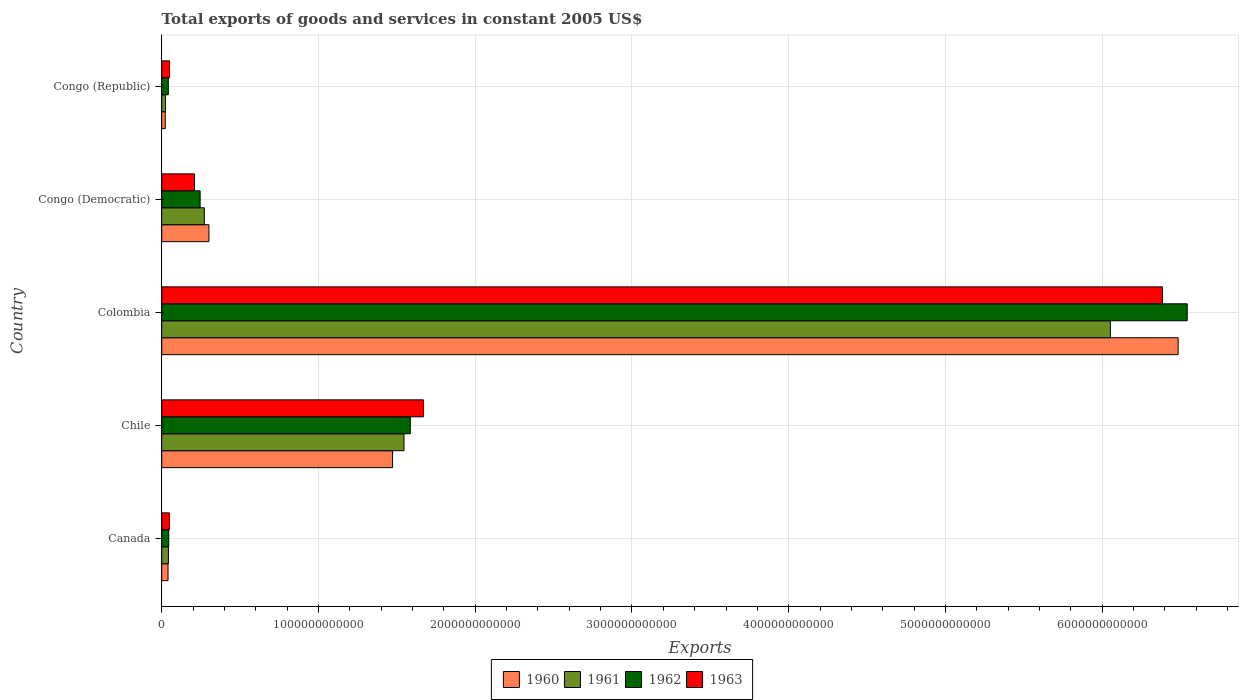How many different coloured bars are there?
Offer a very short reply. 4. How many groups of bars are there?
Your answer should be compact. 5. Are the number of bars per tick equal to the number of legend labels?
Give a very brief answer. Yes. How many bars are there on the 1st tick from the top?
Ensure brevity in your answer.  4. How many bars are there on the 2nd tick from the bottom?
Make the answer very short. 4. What is the label of the 1st group of bars from the top?
Give a very brief answer. Congo (Republic). What is the total exports of goods and services in 1962 in Congo (Republic)?
Your answer should be very brief. 4.20e+1. Across all countries, what is the maximum total exports of goods and services in 1960?
Your answer should be compact. 6.48e+12. Across all countries, what is the minimum total exports of goods and services in 1963?
Give a very brief answer. 4.91e+1. In which country was the total exports of goods and services in 1962 minimum?
Your answer should be very brief. Congo (Republic). What is the total total exports of goods and services in 1960 in the graph?
Provide a short and direct response. 8.32e+12. What is the difference between the total exports of goods and services in 1961 in Canada and that in Congo (Republic)?
Offer a very short reply. 1.87e+1. What is the difference between the total exports of goods and services in 1960 in Colombia and the total exports of goods and services in 1962 in Chile?
Your response must be concise. 4.90e+12. What is the average total exports of goods and services in 1963 per country?
Provide a short and direct response. 1.67e+12. What is the difference between the total exports of goods and services in 1961 and total exports of goods and services in 1963 in Canada?
Provide a short and direct response. -6.12e+09. What is the ratio of the total exports of goods and services in 1960 in Chile to that in Congo (Republic)?
Provide a short and direct response. 65.38. Is the total exports of goods and services in 1963 in Canada less than that in Congo (Democratic)?
Make the answer very short. Yes. Is the difference between the total exports of goods and services in 1961 in Congo (Democratic) and Congo (Republic) greater than the difference between the total exports of goods and services in 1963 in Congo (Democratic) and Congo (Republic)?
Your answer should be very brief. Yes. What is the difference between the highest and the second highest total exports of goods and services in 1962?
Offer a terse response. 4.96e+12. What is the difference between the highest and the lowest total exports of goods and services in 1962?
Offer a terse response. 6.50e+12. Is it the case that in every country, the sum of the total exports of goods and services in 1961 and total exports of goods and services in 1962 is greater than the sum of total exports of goods and services in 1960 and total exports of goods and services in 1963?
Provide a succinct answer. No. What does the 1st bar from the top in Chile represents?
Provide a succinct answer. 1963. How many bars are there?
Give a very brief answer. 20. What is the difference between two consecutive major ticks on the X-axis?
Offer a terse response. 1.00e+12. Are the values on the major ticks of X-axis written in scientific E-notation?
Keep it short and to the point. No. Does the graph contain any zero values?
Make the answer very short. No. Does the graph contain grids?
Give a very brief answer. Yes. How many legend labels are there?
Make the answer very short. 4. How are the legend labels stacked?
Make the answer very short. Horizontal. What is the title of the graph?
Provide a succinct answer. Total exports of goods and services in constant 2005 US$. What is the label or title of the X-axis?
Make the answer very short. Exports. What is the Exports of 1960 in Canada?
Provide a succinct answer. 4.02e+1. What is the Exports in 1961 in Canada?
Provide a short and direct response. 4.29e+1. What is the Exports in 1962 in Canada?
Ensure brevity in your answer.  4.49e+1. What is the Exports in 1963 in Canada?
Provide a succinct answer. 4.91e+1. What is the Exports of 1960 in Chile?
Your answer should be very brief. 1.47e+12. What is the Exports of 1961 in Chile?
Your answer should be very brief. 1.55e+12. What is the Exports of 1962 in Chile?
Your answer should be compact. 1.59e+12. What is the Exports in 1963 in Chile?
Provide a succinct answer. 1.67e+12. What is the Exports of 1960 in Colombia?
Offer a very short reply. 6.48e+12. What is the Exports of 1961 in Colombia?
Your answer should be very brief. 6.05e+12. What is the Exports in 1962 in Colombia?
Offer a very short reply. 6.54e+12. What is the Exports of 1963 in Colombia?
Keep it short and to the point. 6.38e+12. What is the Exports of 1960 in Congo (Democratic)?
Your answer should be very brief. 3.01e+11. What is the Exports of 1961 in Congo (Democratic)?
Provide a succinct answer. 2.72e+11. What is the Exports in 1962 in Congo (Democratic)?
Make the answer very short. 2.45e+11. What is the Exports in 1963 in Congo (Democratic)?
Provide a succinct answer. 2.09e+11. What is the Exports of 1960 in Congo (Republic)?
Ensure brevity in your answer.  2.25e+1. What is the Exports in 1961 in Congo (Republic)?
Give a very brief answer. 2.42e+1. What is the Exports of 1962 in Congo (Republic)?
Provide a succinct answer. 4.20e+1. What is the Exports in 1963 in Congo (Republic)?
Your answer should be very brief. 5.01e+1. Across all countries, what is the maximum Exports of 1960?
Provide a short and direct response. 6.48e+12. Across all countries, what is the maximum Exports of 1961?
Provide a succinct answer. 6.05e+12. Across all countries, what is the maximum Exports in 1962?
Give a very brief answer. 6.54e+12. Across all countries, what is the maximum Exports in 1963?
Make the answer very short. 6.38e+12. Across all countries, what is the minimum Exports of 1960?
Offer a very short reply. 2.25e+1. Across all countries, what is the minimum Exports in 1961?
Make the answer very short. 2.42e+1. Across all countries, what is the minimum Exports of 1962?
Offer a very short reply. 4.20e+1. Across all countries, what is the minimum Exports of 1963?
Make the answer very short. 4.91e+1. What is the total Exports in 1960 in the graph?
Provide a short and direct response. 8.32e+12. What is the total Exports of 1961 in the graph?
Give a very brief answer. 7.94e+12. What is the total Exports of 1962 in the graph?
Give a very brief answer. 8.46e+12. What is the total Exports in 1963 in the graph?
Offer a very short reply. 8.36e+12. What is the difference between the Exports in 1960 in Canada and that in Chile?
Offer a very short reply. -1.43e+12. What is the difference between the Exports of 1961 in Canada and that in Chile?
Offer a terse response. -1.50e+12. What is the difference between the Exports of 1962 in Canada and that in Chile?
Ensure brevity in your answer.  -1.54e+12. What is the difference between the Exports of 1963 in Canada and that in Chile?
Your response must be concise. -1.62e+12. What is the difference between the Exports in 1960 in Canada and that in Colombia?
Keep it short and to the point. -6.44e+12. What is the difference between the Exports of 1961 in Canada and that in Colombia?
Ensure brevity in your answer.  -6.01e+12. What is the difference between the Exports of 1962 in Canada and that in Colombia?
Provide a succinct answer. -6.50e+12. What is the difference between the Exports in 1963 in Canada and that in Colombia?
Offer a very short reply. -6.34e+12. What is the difference between the Exports in 1960 in Canada and that in Congo (Democratic)?
Offer a terse response. -2.61e+11. What is the difference between the Exports in 1961 in Canada and that in Congo (Democratic)?
Your answer should be compact. -2.29e+11. What is the difference between the Exports of 1962 in Canada and that in Congo (Democratic)?
Offer a very short reply. -2.00e+11. What is the difference between the Exports in 1963 in Canada and that in Congo (Democratic)?
Ensure brevity in your answer.  -1.60e+11. What is the difference between the Exports in 1960 in Canada and that in Congo (Republic)?
Offer a very short reply. 1.77e+1. What is the difference between the Exports of 1961 in Canada and that in Congo (Republic)?
Offer a very short reply. 1.87e+1. What is the difference between the Exports in 1962 in Canada and that in Congo (Republic)?
Give a very brief answer. 2.86e+09. What is the difference between the Exports in 1963 in Canada and that in Congo (Republic)?
Keep it short and to the point. -1.07e+09. What is the difference between the Exports in 1960 in Chile and that in Colombia?
Ensure brevity in your answer.  -5.01e+12. What is the difference between the Exports of 1961 in Chile and that in Colombia?
Offer a very short reply. -4.51e+12. What is the difference between the Exports of 1962 in Chile and that in Colombia?
Your response must be concise. -4.96e+12. What is the difference between the Exports in 1963 in Chile and that in Colombia?
Your answer should be compact. -4.71e+12. What is the difference between the Exports of 1960 in Chile and that in Congo (Democratic)?
Provide a succinct answer. 1.17e+12. What is the difference between the Exports in 1961 in Chile and that in Congo (Democratic)?
Offer a terse response. 1.27e+12. What is the difference between the Exports in 1962 in Chile and that in Congo (Democratic)?
Offer a terse response. 1.34e+12. What is the difference between the Exports of 1963 in Chile and that in Congo (Democratic)?
Your response must be concise. 1.46e+12. What is the difference between the Exports of 1960 in Chile and that in Congo (Republic)?
Make the answer very short. 1.45e+12. What is the difference between the Exports of 1961 in Chile and that in Congo (Republic)?
Provide a succinct answer. 1.52e+12. What is the difference between the Exports in 1962 in Chile and that in Congo (Republic)?
Your answer should be very brief. 1.54e+12. What is the difference between the Exports of 1963 in Chile and that in Congo (Republic)?
Your answer should be very brief. 1.62e+12. What is the difference between the Exports of 1960 in Colombia and that in Congo (Democratic)?
Provide a short and direct response. 6.18e+12. What is the difference between the Exports in 1961 in Colombia and that in Congo (Democratic)?
Keep it short and to the point. 5.78e+12. What is the difference between the Exports in 1962 in Colombia and that in Congo (Democratic)?
Give a very brief answer. 6.30e+12. What is the difference between the Exports of 1963 in Colombia and that in Congo (Democratic)?
Provide a succinct answer. 6.17e+12. What is the difference between the Exports of 1960 in Colombia and that in Congo (Republic)?
Make the answer very short. 6.46e+12. What is the difference between the Exports of 1961 in Colombia and that in Congo (Republic)?
Offer a very short reply. 6.03e+12. What is the difference between the Exports of 1962 in Colombia and that in Congo (Republic)?
Ensure brevity in your answer.  6.50e+12. What is the difference between the Exports in 1963 in Colombia and that in Congo (Republic)?
Keep it short and to the point. 6.33e+12. What is the difference between the Exports in 1960 in Congo (Democratic) and that in Congo (Republic)?
Keep it short and to the point. 2.79e+11. What is the difference between the Exports of 1961 in Congo (Democratic) and that in Congo (Republic)?
Ensure brevity in your answer.  2.48e+11. What is the difference between the Exports in 1962 in Congo (Democratic) and that in Congo (Republic)?
Your response must be concise. 2.03e+11. What is the difference between the Exports of 1963 in Congo (Democratic) and that in Congo (Republic)?
Give a very brief answer. 1.59e+11. What is the difference between the Exports of 1960 in Canada and the Exports of 1961 in Chile?
Provide a succinct answer. -1.51e+12. What is the difference between the Exports of 1960 in Canada and the Exports of 1962 in Chile?
Your response must be concise. -1.55e+12. What is the difference between the Exports of 1960 in Canada and the Exports of 1963 in Chile?
Your answer should be compact. -1.63e+12. What is the difference between the Exports of 1961 in Canada and the Exports of 1962 in Chile?
Offer a terse response. -1.54e+12. What is the difference between the Exports of 1961 in Canada and the Exports of 1963 in Chile?
Give a very brief answer. -1.63e+12. What is the difference between the Exports in 1962 in Canada and the Exports in 1963 in Chile?
Give a very brief answer. -1.62e+12. What is the difference between the Exports of 1960 in Canada and the Exports of 1961 in Colombia?
Offer a very short reply. -6.01e+12. What is the difference between the Exports in 1960 in Canada and the Exports in 1962 in Colombia?
Ensure brevity in your answer.  -6.50e+12. What is the difference between the Exports in 1960 in Canada and the Exports in 1963 in Colombia?
Provide a succinct answer. -6.34e+12. What is the difference between the Exports of 1961 in Canada and the Exports of 1962 in Colombia?
Offer a terse response. -6.50e+12. What is the difference between the Exports in 1961 in Canada and the Exports in 1963 in Colombia?
Offer a very short reply. -6.34e+12. What is the difference between the Exports in 1962 in Canada and the Exports in 1963 in Colombia?
Give a very brief answer. -6.34e+12. What is the difference between the Exports in 1960 in Canada and the Exports in 1961 in Congo (Democratic)?
Your response must be concise. -2.32e+11. What is the difference between the Exports of 1960 in Canada and the Exports of 1962 in Congo (Democratic)?
Your answer should be compact. -2.05e+11. What is the difference between the Exports of 1960 in Canada and the Exports of 1963 in Congo (Democratic)?
Make the answer very short. -1.69e+11. What is the difference between the Exports of 1961 in Canada and the Exports of 1962 in Congo (Democratic)?
Offer a terse response. -2.02e+11. What is the difference between the Exports in 1961 in Canada and the Exports in 1963 in Congo (Democratic)?
Provide a succinct answer. -1.67e+11. What is the difference between the Exports of 1962 in Canada and the Exports of 1963 in Congo (Democratic)?
Your response must be concise. -1.65e+11. What is the difference between the Exports in 1960 in Canada and the Exports in 1961 in Congo (Republic)?
Provide a short and direct response. 1.60e+1. What is the difference between the Exports in 1960 in Canada and the Exports in 1962 in Congo (Republic)?
Your answer should be compact. -1.85e+09. What is the difference between the Exports of 1960 in Canada and the Exports of 1963 in Congo (Republic)?
Keep it short and to the point. -9.92e+09. What is the difference between the Exports of 1961 in Canada and the Exports of 1962 in Congo (Republic)?
Your response must be concise. 8.81e+08. What is the difference between the Exports of 1961 in Canada and the Exports of 1963 in Congo (Republic)?
Provide a succinct answer. -7.19e+09. What is the difference between the Exports in 1962 in Canada and the Exports in 1963 in Congo (Republic)?
Offer a very short reply. -5.21e+09. What is the difference between the Exports of 1960 in Chile and the Exports of 1961 in Colombia?
Your response must be concise. -4.58e+12. What is the difference between the Exports of 1960 in Chile and the Exports of 1962 in Colombia?
Your answer should be very brief. -5.07e+12. What is the difference between the Exports in 1960 in Chile and the Exports in 1963 in Colombia?
Give a very brief answer. -4.91e+12. What is the difference between the Exports in 1961 in Chile and the Exports in 1962 in Colombia?
Provide a short and direct response. -5.00e+12. What is the difference between the Exports of 1961 in Chile and the Exports of 1963 in Colombia?
Your answer should be very brief. -4.84e+12. What is the difference between the Exports of 1962 in Chile and the Exports of 1963 in Colombia?
Give a very brief answer. -4.80e+12. What is the difference between the Exports of 1960 in Chile and the Exports of 1961 in Congo (Democratic)?
Keep it short and to the point. 1.20e+12. What is the difference between the Exports in 1960 in Chile and the Exports in 1962 in Congo (Democratic)?
Provide a succinct answer. 1.23e+12. What is the difference between the Exports of 1960 in Chile and the Exports of 1963 in Congo (Democratic)?
Make the answer very short. 1.26e+12. What is the difference between the Exports of 1961 in Chile and the Exports of 1962 in Congo (Democratic)?
Provide a short and direct response. 1.30e+12. What is the difference between the Exports in 1961 in Chile and the Exports in 1963 in Congo (Democratic)?
Offer a very short reply. 1.34e+12. What is the difference between the Exports in 1962 in Chile and the Exports in 1963 in Congo (Democratic)?
Provide a succinct answer. 1.38e+12. What is the difference between the Exports in 1960 in Chile and the Exports in 1961 in Congo (Republic)?
Give a very brief answer. 1.45e+12. What is the difference between the Exports of 1960 in Chile and the Exports of 1962 in Congo (Republic)?
Make the answer very short. 1.43e+12. What is the difference between the Exports of 1960 in Chile and the Exports of 1963 in Congo (Republic)?
Your answer should be very brief. 1.42e+12. What is the difference between the Exports of 1961 in Chile and the Exports of 1962 in Congo (Republic)?
Your answer should be very brief. 1.50e+12. What is the difference between the Exports in 1961 in Chile and the Exports in 1963 in Congo (Republic)?
Keep it short and to the point. 1.50e+12. What is the difference between the Exports of 1962 in Chile and the Exports of 1963 in Congo (Republic)?
Give a very brief answer. 1.54e+12. What is the difference between the Exports in 1960 in Colombia and the Exports in 1961 in Congo (Democratic)?
Your answer should be compact. 6.21e+12. What is the difference between the Exports in 1960 in Colombia and the Exports in 1962 in Congo (Democratic)?
Offer a very short reply. 6.24e+12. What is the difference between the Exports of 1960 in Colombia and the Exports of 1963 in Congo (Democratic)?
Provide a succinct answer. 6.27e+12. What is the difference between the Exports of 1961 in Colombia and the Exports of 1962 in Congo (Democratic)?
Ensure brevity in your answer.  5.81e+12. What is the difference between the Exports in 1961 in Colombia and the Exports in 1963 in Congo (Democratic)?
Provide a short and direct response. 5.84e+12. What is the difference between the Exports in 1962 in Colombia and the Exports in 1963 in Congo (Democratic)?
Your response must be concise. 6.33e+12. What is the difference between the Exports in 1960 in Colombia and the Exports in 1961 in Congo (Republic)?
Give a very brief answer. 6.46e+12. What is the difference between the Exports in 1960 in Colombia and the Exports in 1962 in Congo (Republic)?
Offer a very short reply. 6.44e+12. What is the difference between the Exports of 1960 in Colombia and the Exports of 1963 in Congo (Republic)?
Your response must be concise. 6.43e+12. What is the difference between the Exports in 1961 in Colombia and the Exports in 1962 in Congo (Republic)?
Ensure brevity in your answer.  6.01e+12. What is the difference between the Exports in 1961 in Colombia and the Exports in 1963 in Congo (Republic)?
Your answer should be very brief. 6.00e+12. What is the difference between the Exports in 1962 in Colombia and the Exports in 1963 in Congo (Republic)?
Ensure brevity in your answer.  6.49e+12. What is the difference between the Exports of 1960 in Congo (Democratic) and the Exports of 1961 in Congo (Republic)?
Your answer should be very brief. 2.77e+11. What is the difference between the Exports of 1960 in Congo (Democratic) and the Exports of 1962 in Congo (Republic)?
Offer a terse response. 2.59e+11. What is the difference between the Exports of 1960 in Congo (Democratic) and the Exports of 1963 in Congo (Republic)?
Give a very brief answer. 2.51e+11. What is the difference between the Exports of 1961 in Congo (Democratic) and the Exports of 1962 in Congo (Republic)?
Offer a terse response. 2.30e+11. What is the difference between the Exports of 1961 in Congo (Democratic) and the Exports of 1963 in Congo (Republic)?
Provide a succinct answer. 2.22e+11. What is the difference between the Exports in 1962 in Congo (Democratic) and the Exports in 1963 in Congo (Republic)?
Provide a short and direct response. 1.95e+11. What is the average Exports in 1960 per country?
Offer a terse response. 1.66e+12. What is the average Exports in 1961 per country?
Offer a terse response. 1.59e+12. What is the average Exports of 1962 per country?
Provide a short and direct response. 1.69e+12. What is the average Exports of 1963 per country?
Ensure brevity in your answer.  1.67e+12. What is the difference between the Exports of 1960 and Exports of 1961 in Canada?
Ensure brevity in your answer.  -2.73e+09. What is the difference between the Exports in 1960 and Exports in 1962 in Canada?
Keep it short and to the point. -4.72e+09. What is the difference between the Exports in 1960 and Exports in 1963 in Canada?
Offer a very short reply. -8.86e+09. What is the difference between the Exports in 1961 and Exports in 1962 in Canada?
Your answer should be compact. -1.98e+09. What is the difference between the Exports in 1961 and Exports in 1963 in Canada?
Make the answer very short. -6.12e+09. What is the difference between the Exports in 1962 and Exports in 1963 in Canada?
Your answer should be very brief. -4.14e+09. What is the difference between the Exports of 1960 and Exports of 1961 in Chile?
Ensure brevity in your answer.  -7.28e+1. What is the difference between the Exports in 1960 and Exports in 1962 in Chile?
Give a very brief answer. -1.13e+11. What is the difference between the Exports of 1960 and Exports of 1963 in Chile?
Provide a short and direct response. -1.97e+11. What is the difference between the Exports of 1961 and Exports of 1962 in Chile?
Make the answer very short. -4.03e+1. What is the difference between the Exports of 1961 and Exports of 1963 in Chile?
Keep it short and to the point. -1.24e+11. What is the difference between the Exports of 1962 and Exports of 1963 in Chile?
Keep it short and to the point. -8.37e+1. What is the difference between the Exports in 1960 and Exports in 1961 in Colombia?
Ensure brevity in your answer.  4.32e+11. What is the difference between the Exports in 1960 and Exports in 1962 in Colombia?
Your response must be concise. -5.79e+1. What is the difference between the Exports of 1960 and Exports of 1963 in Colombia?
Your answer should be compact. 1.00e+11. What is the difference between the Exports of 1961 and Exports of 1962 in Colombia?
Your answer should be very brief. -4.90e+11. What is the difference between the Exports of 1961 and Exports of 1963 in Colombia?
Provide a succinct answer. -3.32e+11. What is the difference between the Exports of 1962 and Exports of 1963 in Colombia?
Keep it short and to the point. 1.58e+11. What is the difference between the Exports in 1960 and Exports in 1961 in Congo (Democratic)?
Your answer should be compact. 2.94e+1. What is the difference between the Exports of 1960 and Exports of 1962 in Congo (Democratic)?
Your answer should be compact. 5.61e+1. What is the difference between the Exports in 1960 and Exports in 1963 in Congo (Democratic)?
Ensure brevity in your answer.  9.17e+1. What is the difference between the Exports in 1961 and Exports in 1962 in Congo (Democratic)?
Give a very brief answer. 2.67e+1. What is the difference between the Exports in 1961 and Exports in 1963 in Congo (Democratic)?
Make the answer very short. 6.23e+1. What is the difference between the Exports of 1962 and Exports of 1963 in Congo (Democratic)?
Your answer should be very brief. 3.56e+1. What is the difference between the Exports of 1960 and Exports of 1961 in Congo (Republic)?
Your answer should be very brief. -1.69e+09. What is the difference between the Exports in 1960 and Exports in 1962 in Congo (Republic)?
Offer a terse response. -1.95e+1. What is the difference between the Exports of 1960 and Exports of 1963 in Congo (Republic)?
Your answer should be compact. -2.76e+1. What is the difference between the Exports of 1961 and Exports of 1962 in Congo (Republic)?
Ensure brevity in your answer.  -1.78e+1. What is the difference between the Exports of 1961 and Exports of 1963 in Congo (Republic)?
Offer a very short reply. -2.59e+1. What is the difference between the Exports of 1962 and Exports of 1963 in Congo (Republic)?
Your answer should be compact. -8.07e+09. What is the ratio of the Exports of 1960 in Canada to that in Chile?
Offer a very short reply. 0.03. What is the ratio of the Exports of 1961 in Canada to that in Chile?
Offer a very short reply. 0.03. What is the ratio of the Exports of 1962 in Canada to that in Chile?
Offer a very short reply. 0.03. What is the ratio of the Exports of 1963 in Canada to that in Chile?
Provide a succinct answer. 0.03. What is the ratio of the Exports in 1960 in Canada to that in Colombia?
Offer a very short reply. 0.01. What is the ratio of the Exports in 1961 in Canada to that in Colombia?
Your answer should be very brief. 0.01. What is the ratio of the Exports in 1962 in Canada to that in Colombia?
Your answer should be very brief. 0.01. What is the ratio of the Exports in 1963 in Canada to that in Colombia?
Offer a very short reply. 0.01. What is the ratio of the Exports of 1960 in Canada to that in Congo (Democratic)?
Keep it short and to the point. 0.13. What is the ratio of the Exports in 1961 in Canada to that in Congo (Democratic)?
Keep it short and to the point. 0.16. What is the ratio of the Exports in 1962 in Canada to that in Congo (Democratic)?
Make the answer very short. 0.18. What is the ratio of the Exports in 1963 in Canada to that in Congo (Democratic)?
Make the answer very short. 0.23. What is the ratio of the Exports of 1960 in Canada to that in Congo (Republic)?
Your answer should be compact. 1.78. What is the ratio of the Exports of 1961 in Canada to that in Congo (Republic)?
Offer a very short reply. 1.77. What is the ratio of the Exports in 1962 in Canada to that in Congo (Republic)?
Ensure brevity in your answer.  1.07. What is the ratio of the Exports in 1963 in Canada to that in Congo (Republic)?
Make the answer very short. 0.98. What is the ratio of the Exports in 1960 in Chile to that in Colombia?
Your answer should be very brief. 0.23. What is the ratio of the Exports in 1961 in Chile to that in Colombia?
Ensure brevity in your answer.  0.26. What is the ratio of the Exports in 1962 in Chile to that in Colombia?
Ensure brevity in your answer.  0.24. What is the ratio of the Exports of 1963 in Chile to that in Colombia?
Keep it short and to the point. 0.26. What is the ratio of the Exports of 1960 in Chile to that in Congo (Democratic)?
Ensure brevity in your answer.  4.89. What is the ratio of the Exports in 1961 in Chile to that in Congo (Democratic)?
Your response must be concise. 5.69. What is the ratio of the Exports of 1962 in Chile to that in Congo (Democratic)?
Provide a short and direct response. 6.47. What is the ratio of the Exports of 1963 in Chile to that in Congo (Democratic)?
Keep it short and to the point. 7.97. What is the ratio of the Exports of 1960 in Chile to that in Congo (Republic)?
Make the answer very short. 65.38. What is the ratio of the Exports of 1961 in Chile to that in Congo (Republic)?
Offer a very short reply. 63.82. What is the ratio of the Exports in 1962 in Chile to that in Congo (Republic)?
Provide a succinct answer. 37.72. What is the ratio of the Exports in 1963 in Chile to that in Congo (Republic)?
Ensure brevity in your answer.  33.31. What is the ratio of the Exports of 1960 in Colombia to that in Congo (Democratic)?
Provide a short and direct response. 21.53. What is the ratio of the Exports in 1961 in Colombia to that in Congo (Democratic)?
Offer a very short reply. 22.27. What is the ratio of the Exports of 1962 in Colombia to that in Congo (Democratic)?
Make the answer very short. 26.7. What is the ratio of the Exports of 1963 in Colombia to that in Congo (Democratic)?
Make the answer very short. 30.48. What is the ratio of the Exports of 1960 in Colombia to that in Congo (Republic)?
Offer a terse response. 287.84. What is the ratio of the Exports of 1961 in Colombia to that in Congo (Republic)?
Make the answer very short. 249.91. What is the ratio of the Exports in 1962 in Colombia to that in Congo (Republic)?
Your response must be concise. 155.58. What is the ratio of the Exports of 1963 in Colombia to that in Congo (Republic)?
Offer a terse response. 127.37. What is the ratio of the Exports in 1960 in Congo (Democratic) to that in Congo (Republic)?
Provide a succinct answer. 13.37. What is the ratio of the Exports in 1961 in Congo (Democratic) to that in Congo (Republic)?
Ensure brevity in your answer.  11.22. What is the ratio of the Exports in 1962 in Congo (Democratic) to that in Congo (Republic)?
Ensure brevity in your answer.  5.83. What is the ratio of the Exports of 1963 in Congo (Democratic) to that in Congo (Republic)?
Ensure brevity in your answer.  4.18. What is the difference between the highest and the second highest Exports in 1960?
Give a very brief answer. 5.01e+12. What is the difference between the highest and the second highest Exports in 1961?
Provide a succinct answer. 4.51e+12. What is the difference between the highest and the second highest Exports of 1962?
Your answer should be compact. 4.96e+12. What is the difference between the highest and the second highest Exports in 1963?
Make the answer very short. 4.71e+12. What is the difference between the highest and the lowest Exports of 1960?
Make the answer very short. 6.46e+12. What is the difference between the highest and the lowest Exports in 1961?
Your answer should be compact. 6.03e+12. What is the difference between the highest and the lowest Exports in 1962?
Offer a very short reply. 6.50e+12. What is the difference between the highest and the lowest Exports in 1963?
Your answer should be very brief. 6.34e+12. 